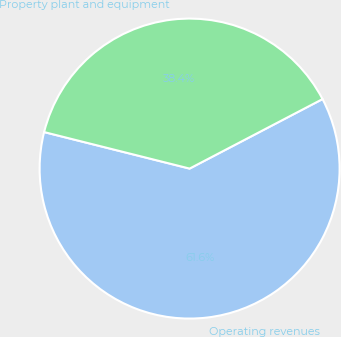<chart> <loc_0><loc_0><loc_500><loc_500><pie_chart><fcel>Operating revenues<fcel>Property plant and equipment<nl><fcel>61.58%<fcel>38.42%<nl></chart> 